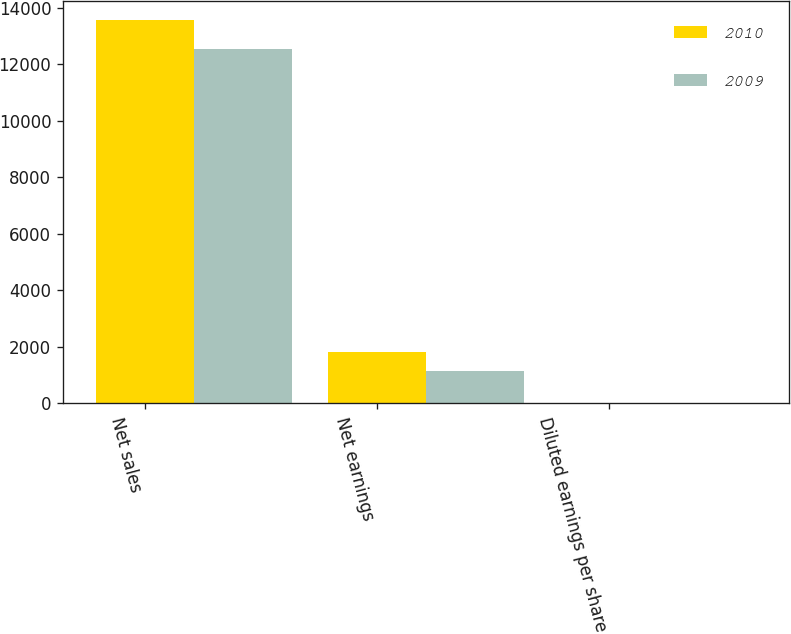<chart> <loc_0><loc_0><loc_500><loc_500><stacked_bar_chart><ecel><fcel>Net sales<fcel>Net earnings<fcel>Diluted earnings per share<nl><fcel>2010<fcel>13546.8<fcel>1806.1<fcel>2.66<nl><fcel>2009<fcel>12529.5<fcel>1156.2<fcel>1.74<nl></chart> 